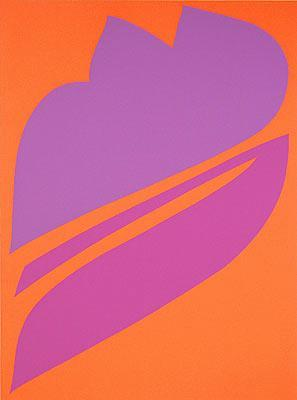What is this photo about? This image is a striking example of abstract art featuring a vivid orange background with a large purple shape at its center. The shape, resembling a stylized leaf, consists of three intersecting curved lines that create a visual focus. The use of bright contrasting colors not only draws the viewer's eye but also evokes a sense of energy and movement. The simplicity of the composition, paired with the dynamic color palette, gives this artwork a modern and impactful aesthetic. It could represent themes of growth, dynamism, or nature in an abstract way. 